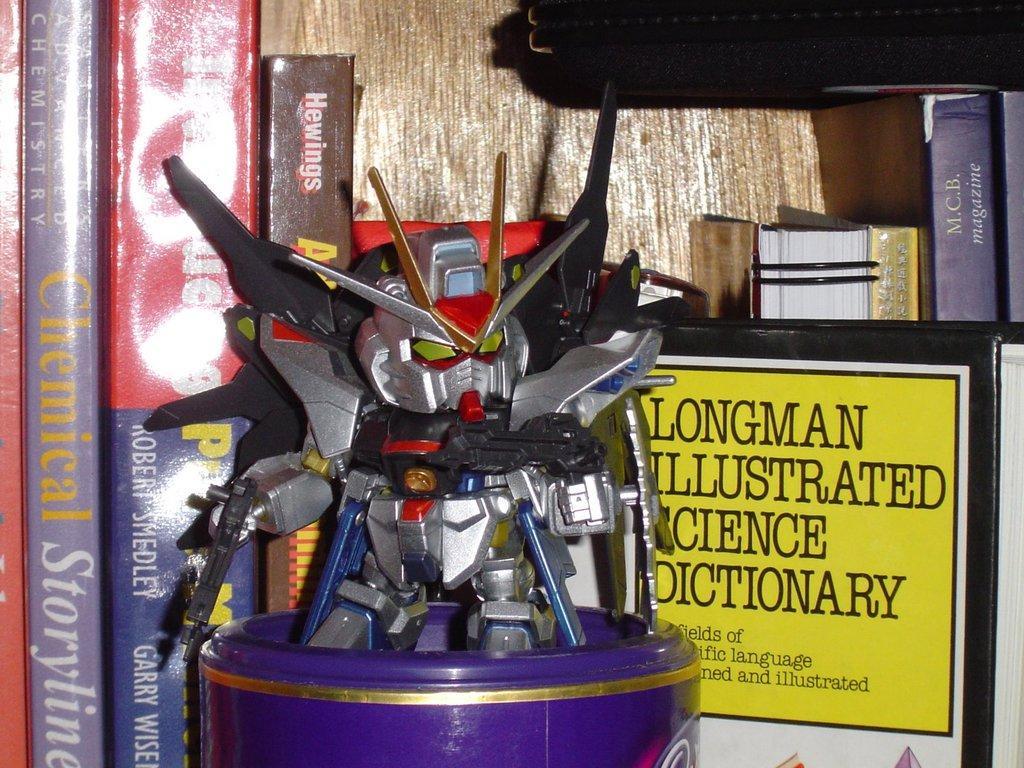Could you give a brief overview of what you see in this image? Here in this picture in the front we can see a robot toy present on a box over there and behind that we can see number of books present in the shelf over there. 